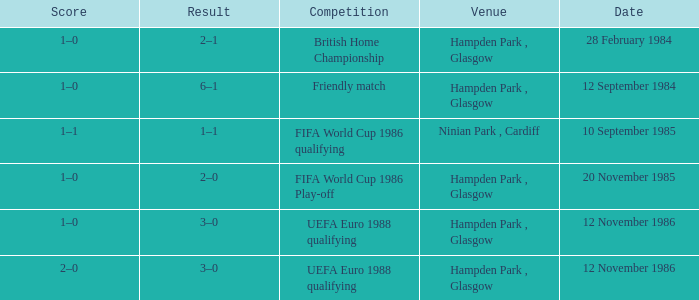What is the Score of the Fifa World Cup 1986 Play-off Competition? 1–0. 